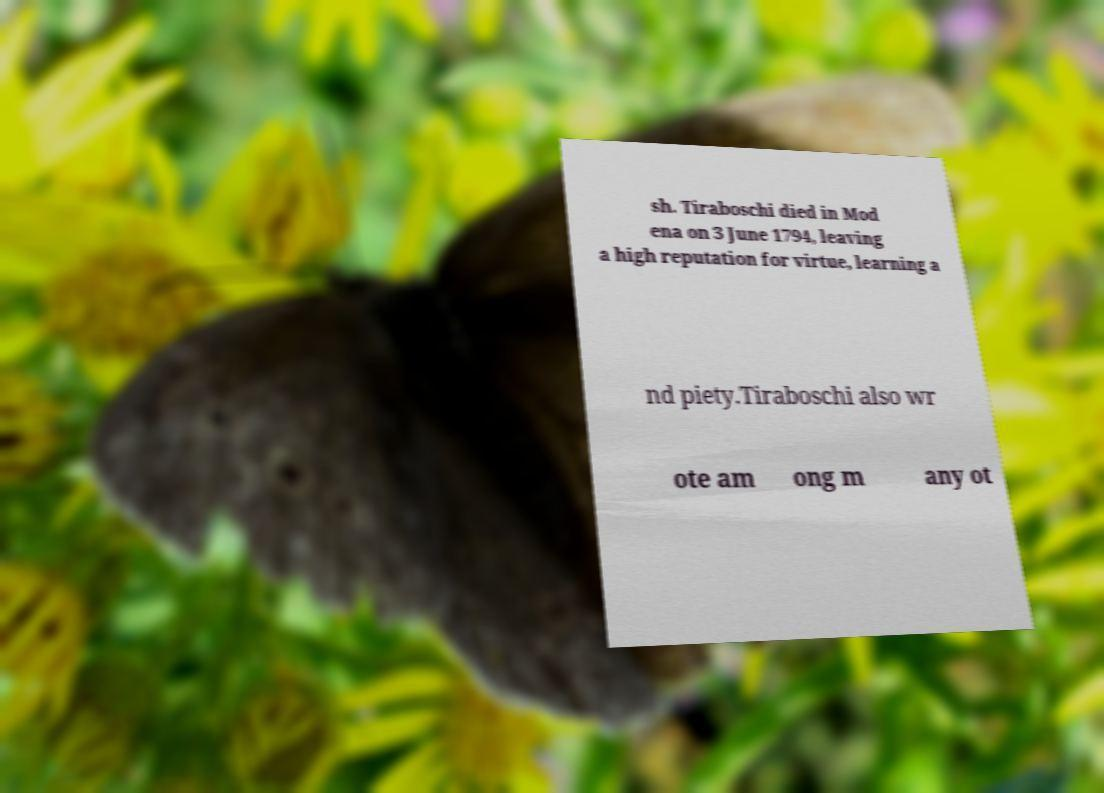Please read and relay the text visible in this image. What does it say? sh. Tiraboschi died in Mod ena on 3 June 1794, leaving a high reputation for virtue, learning a nd piety.Tiraboschi also wr ote am ong m any ot 